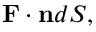<formula> <loc_0><loc_0><loc_500><loc_500>F \cdot n d S ,</formula> 